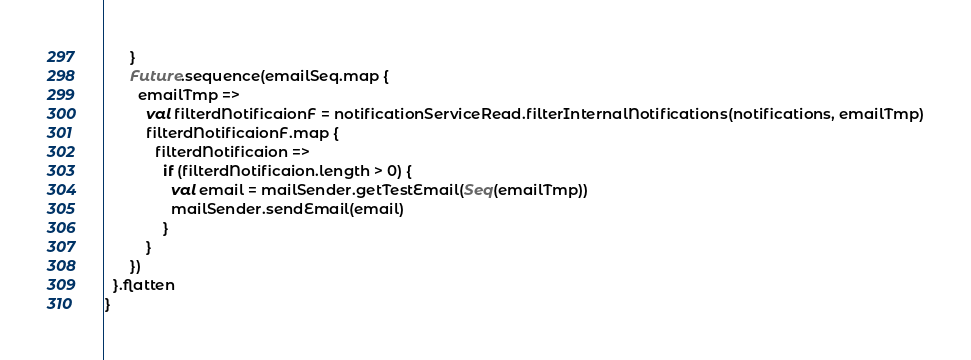Convert code to text. <code><loc_0><loc_0><loc_500><loc_500><_Scala_>      }
      Future.sequence(emailSeq.map {
        emailTmp =>
          val filterdNotificaionF = notificationServiceRead.filterInternalNotifications(notifications, emailTmp)
          filterdNotificaionF.map {
            filterdNotificaion =>
              if (filterdNotificaion.length > 0) {
                val email = mailSender.getTestEmail(Seq(emailTmp))
                mailSender.sendEmail(email)
              }
          }
      })
  }.flatten
}</code> 